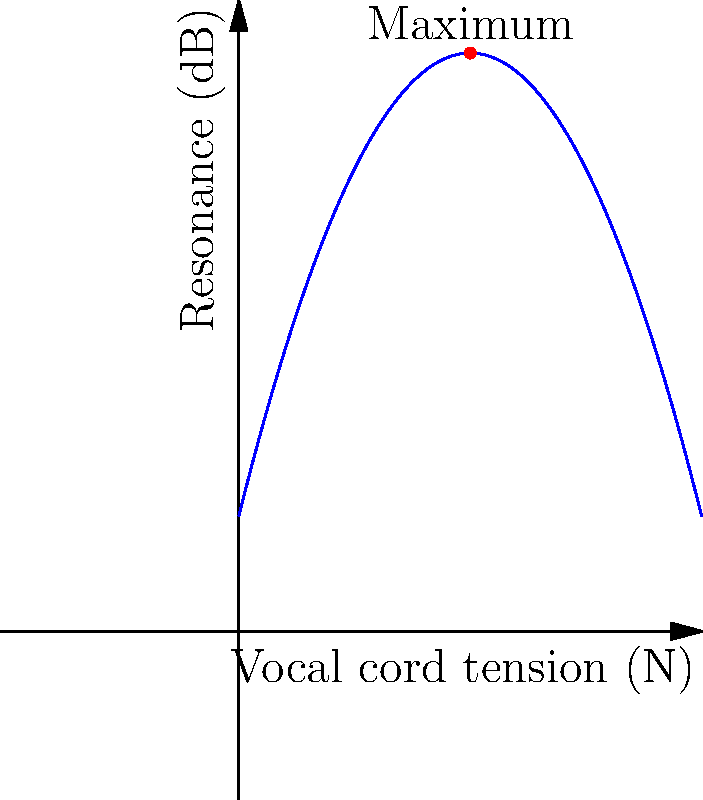A vocal coach models the relationship between vocal cord tension and resonance using the function $R(t) = -0.5t^2 + 4t + 2$, where $R$ is the resonance in decibels (dB) and $t$ is the vocal cord tension in Newtons (N). Find the optimal vocal cord tension that maximizes resonance, and calculate the maximum resonance achieved. To find the optimal vocal cord tension and maximum resonance, we need to follow these steps:

1) The function $R(t) = -0.5t^2 + 4t + 2$ is a parabola that opens downward (negative coefficient of $t^2$).

2) The maximum point of a parabola occurs at the vertex. For a quadratic function in the form $f(x) = ax^2 + bx + c$, the x-coordinate of the vertex is given by $x = -\frac{b}{2a}$.

3) In our case, $a = -0.5$, $b = 4$, and $c = 2$. Let's calculate the optimal tension:

   $t = -\frac{b}{2a} = -\frac{4}{2(-0.5)} = -\frac{4}{-1} = 4$ N

4) To find the maximum resonance, we substitute this t-value back into the original function:

   $R(4) = -0.5(4)^2 + 4(4) + 2$
         $= -0.5(16) + 16 + 2$
         $= -8 + 16 + 2$
         $= 10$ dB

Therefore, the optimal vocal cord tension is 4 N, which results in a maximum resonance of 10 dB.
Answer: Optimal tension: 4 N; Maximum resonance: 10 dB 